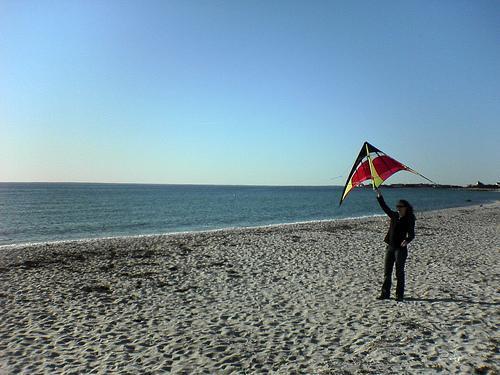How many men are in the photo?
Give a very brief answer. 0. How many bears are there?
Give a very brief answer. 0. 